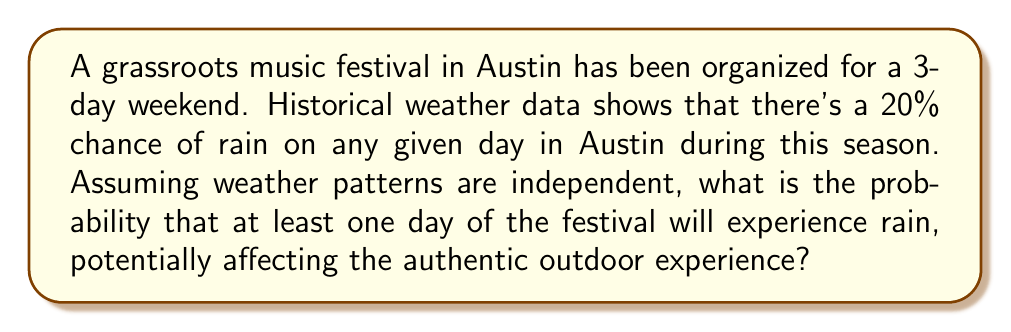Can you solve this math problem? Let's approach this step-by-step:

1) First, let's define our events:
   Let R be the event that it rains on a given day.
   P(R) = 0.20 (20% chance of rain on any day)

2) We want to find the probability of rain on at least one day out of three. It's easier to calculate the probability of the complement event: no rain on any of the three days.

3) The probability of no rain on a single day is:
   P(not R) = 1 - P(R) = 1 - 0.20 = 0.80

4) Since the weather patterns are assumed to be independent, we can use the multiplication rule. The probability of no rain for all three days is:
   P(no rain for 3 days) = $0.80 \times 0.80 \times 0.80 = 0.80^3 = 0.512$

5) Therefore, the probability of at least one day with rain is the complement of this:
   P(at least one day with rain) = 1 - P(no rain for 3 days)
                                  = $1 - 0.512 = 0.488$

6) Converting to a percentage:
   $0.488 \times 100\% = 48.8\%$

Thus, there is a 48.8% chance that at least one day of the festival will experience rain, potentially affecting the authentic outdoor experience.
Answer: 48.8% 